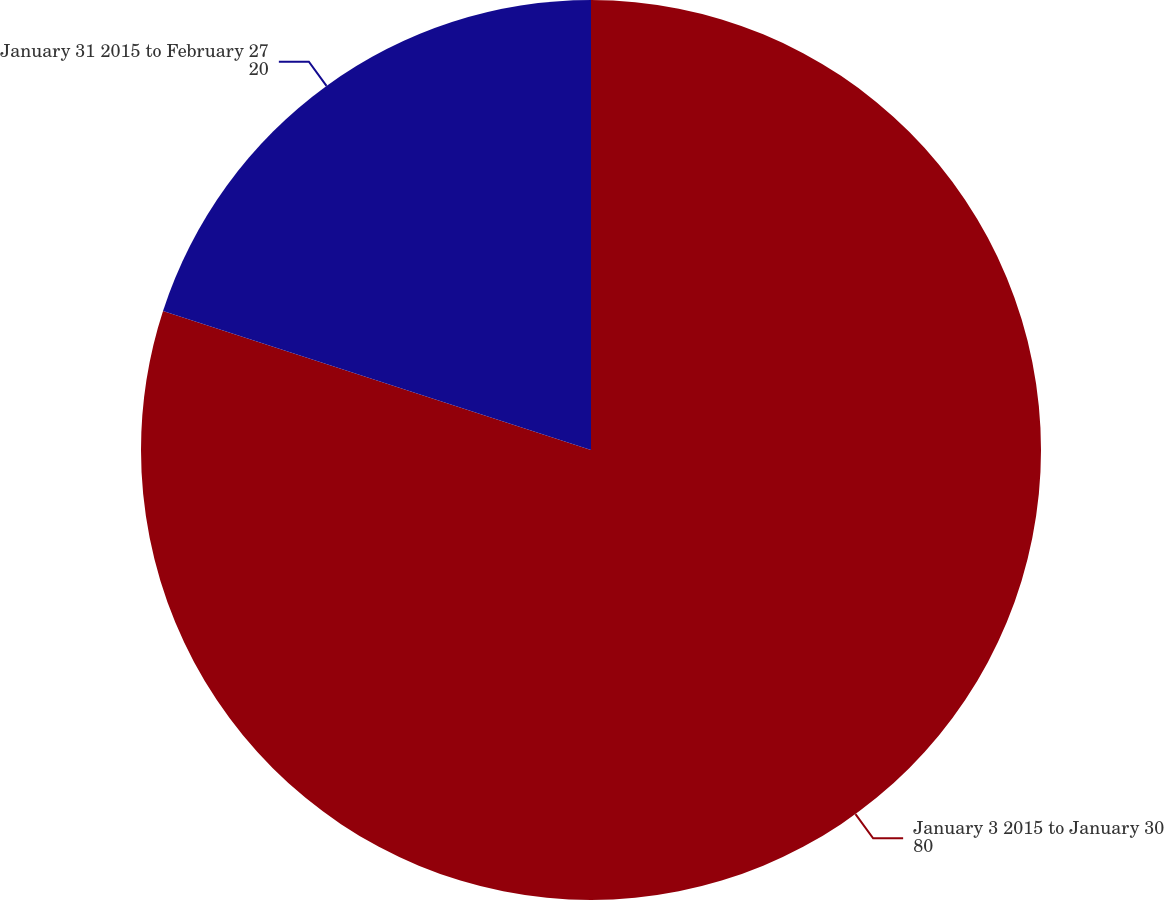<chart> <loc_0><loc_0><loc_500><loc_500><pie_chart><fcel>January 3 2015 to January 30<fcel>January 31 2015 to February 27<nl><fcel>80.0%<fcel>20.0%<nl></chart> 